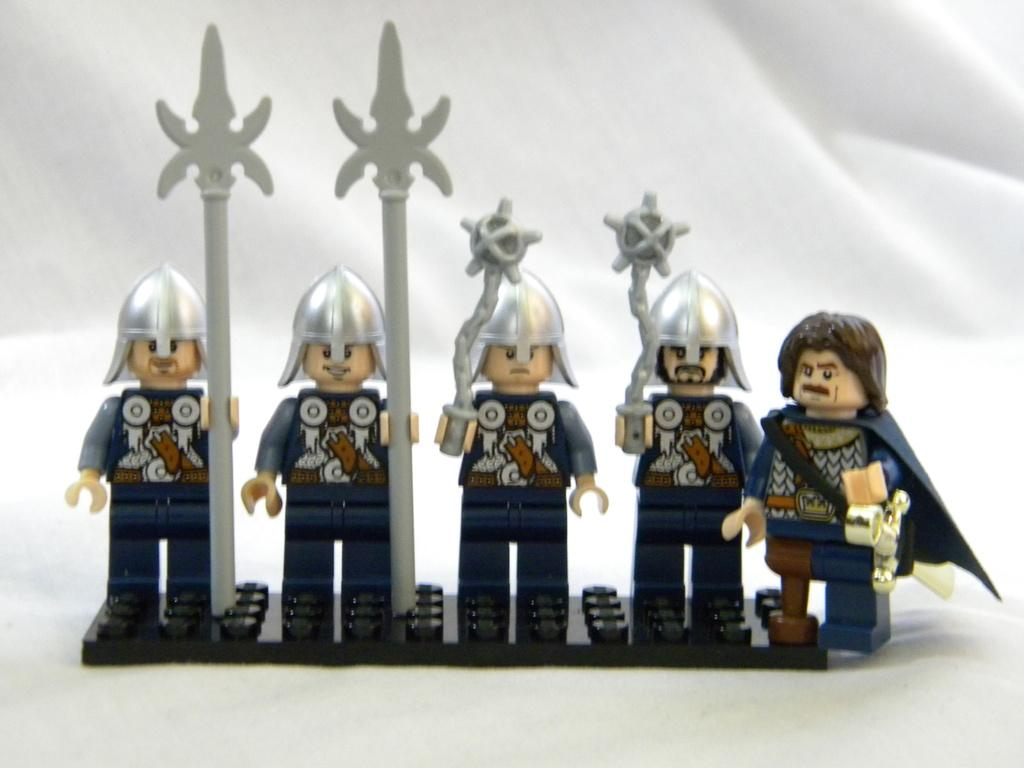What objects are present in the image? There are toys in the image. Where are the toys located? The toys are on white clothes. Can you see a goose playing with the toys on the white clothes in the image? There is no goose present in the image; it only features toys on white clothes. What type of bedroom is shown in the image? The image does not depict a bedroom; it only shows toys on white clothes. 